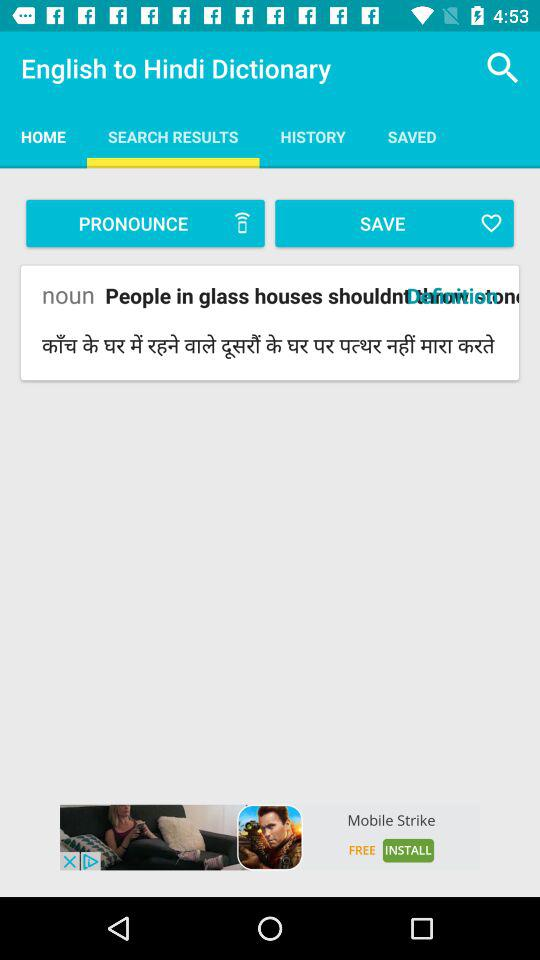Which tab is selected? The selected tab is "SEARCH RESULTS". 